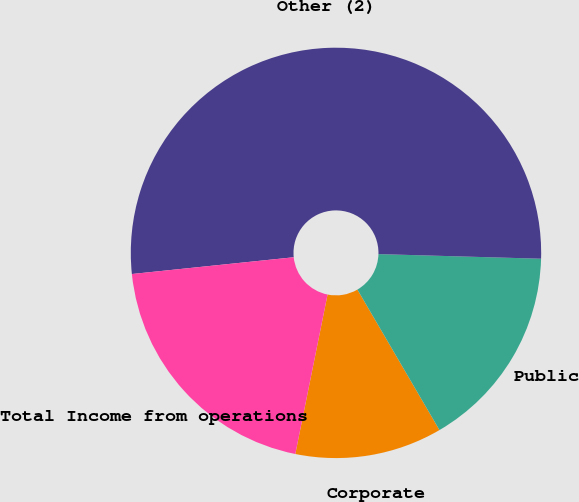Convert chart. <chart><loc_0><loc_0><loc_500><loc_500><pie_chart><fcel>Corporate<fcel>Public<fcel>Other (2)<fcel>Total Income from operations<nl><fcel>11.59%<fcel>16.13%<fcel>52.09%<fcel>20.18%<nl></chart> 